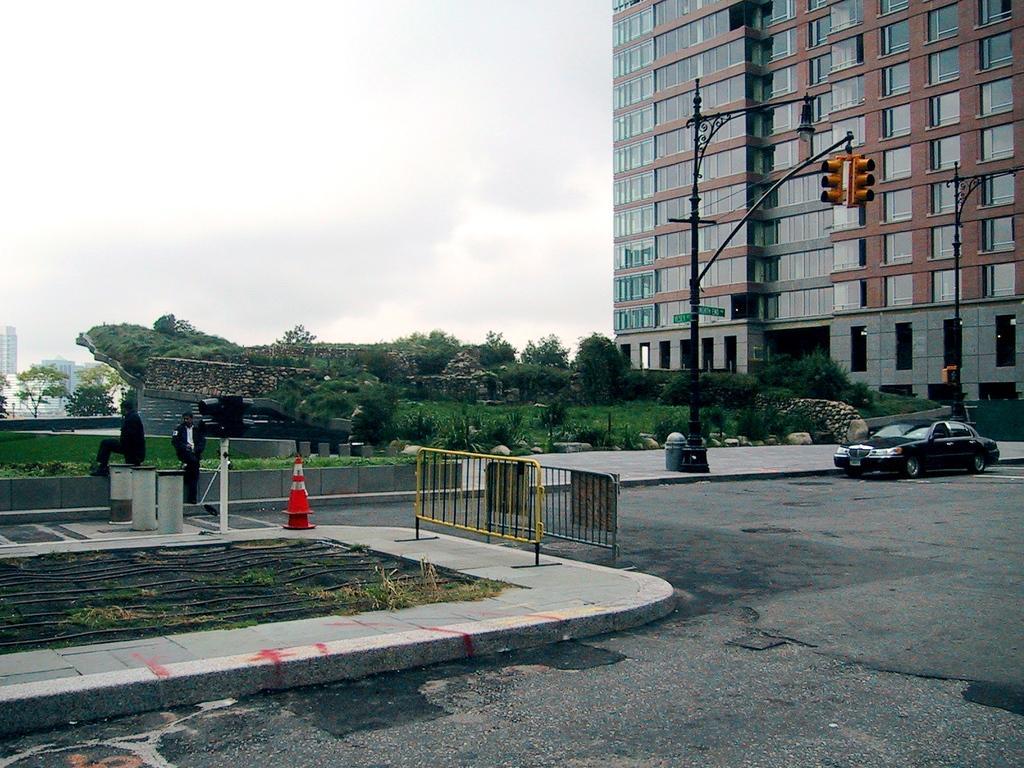Please provide a concise description of this image. In this image there is a building on the right side top. In front of the building there is a garden. In the garden there are so many plants. At the top there is the sky. In the middle there is a pole on the footpath. To the pole there are traffic signal lights. There is a car parked beside the footpath. On the left side there is a fence. Beside the fence there are three pillars and safety cones. At the bottom there is road. 